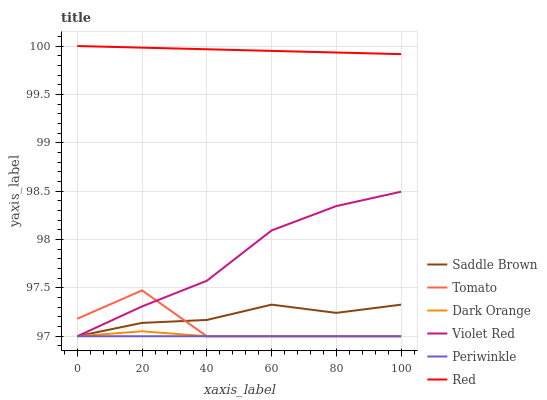Does Periwinkle have the minimum area under the curve?
Answer yes or no. Yes. Does Red have the maximum area under the curve?
Answer yes or no. Yes. Does Dark Orange have the minimum area under the curve?
Answer yes or no. No. Does Dark Orange have the maximum area under the curve?
Answer yes or no. No. Is Periwinkle the smoothest?
Answer yes or no. Yes. Is Tomato the roughest?
Answer yes or no. Yes. Is Dark Orange the smoothest?
Answer yes or no. No. Is Dark Orange the roughest?
Answer yes or no. No. Does Tomato have the lowest value?
Answer yes or no. Yes. Does Red have the lowest value?
Answer yes or no. No. Does Red have the highest value?
Answer yes or no. Yes. Does Dark Orange have the highest value?
Answer yes or no. No. Is Tomato less than Red?
Answer yes or no. Yes. Is Red greater than Saddle Brown?
Answer yes or no. Yes. Does Violet Red intersect Periwinkle?
Answer yes or no. Yes. Is Violet Red less than Periwinkle?
Answer yes or no. No. Is Violet Red greater than Periwinkle?
Answer yes or no. No. Does Tomato intersect Red?
Answer yes or no. No. 